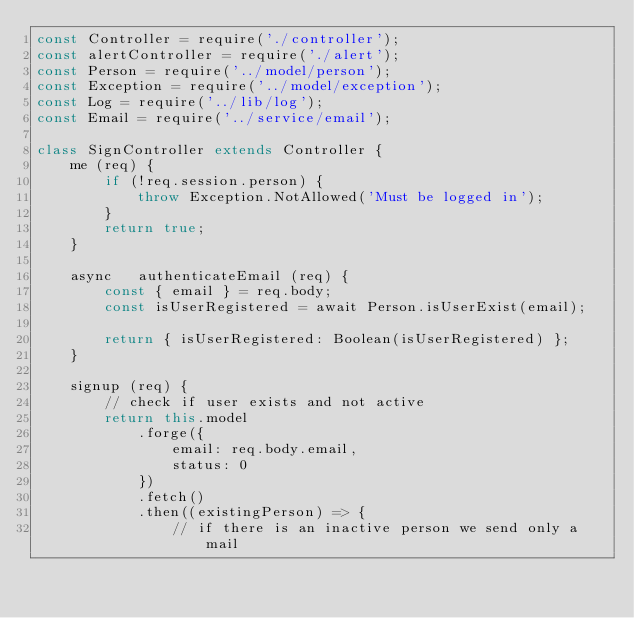Convert code to text. <code><loc_0><loc_0><loc_500><loc_500><_JavaScript_>const Controller = require('./controller');
const alertController = require('./alert');
const Person = require('../model/person');
const Exception = require('../model/exception');
const Log = require('../lib/log');
const Email = require('../service/email');

class SignController extends Controller {
	me (req) {
		if (!req.session.person) {
			throw Exception.NotAllowed('Must be logged in');
		}
		return true;
	}

	async	authenticateEmail (req) {
		const { email } = req.body;
		const isUserRegistered = await Person.isUserExist(email);

		return { isUserRegistered: Boolean(isUserRegistered) };
	}

	signup (req) {
		// check if user exists and not active
		return this.model
			.forge({
				email: req.body.email,
				status: 0
			})
			.fetch()
			.then((existingPerson) => {
				// if there is an inactive person we send only a mail</code> 